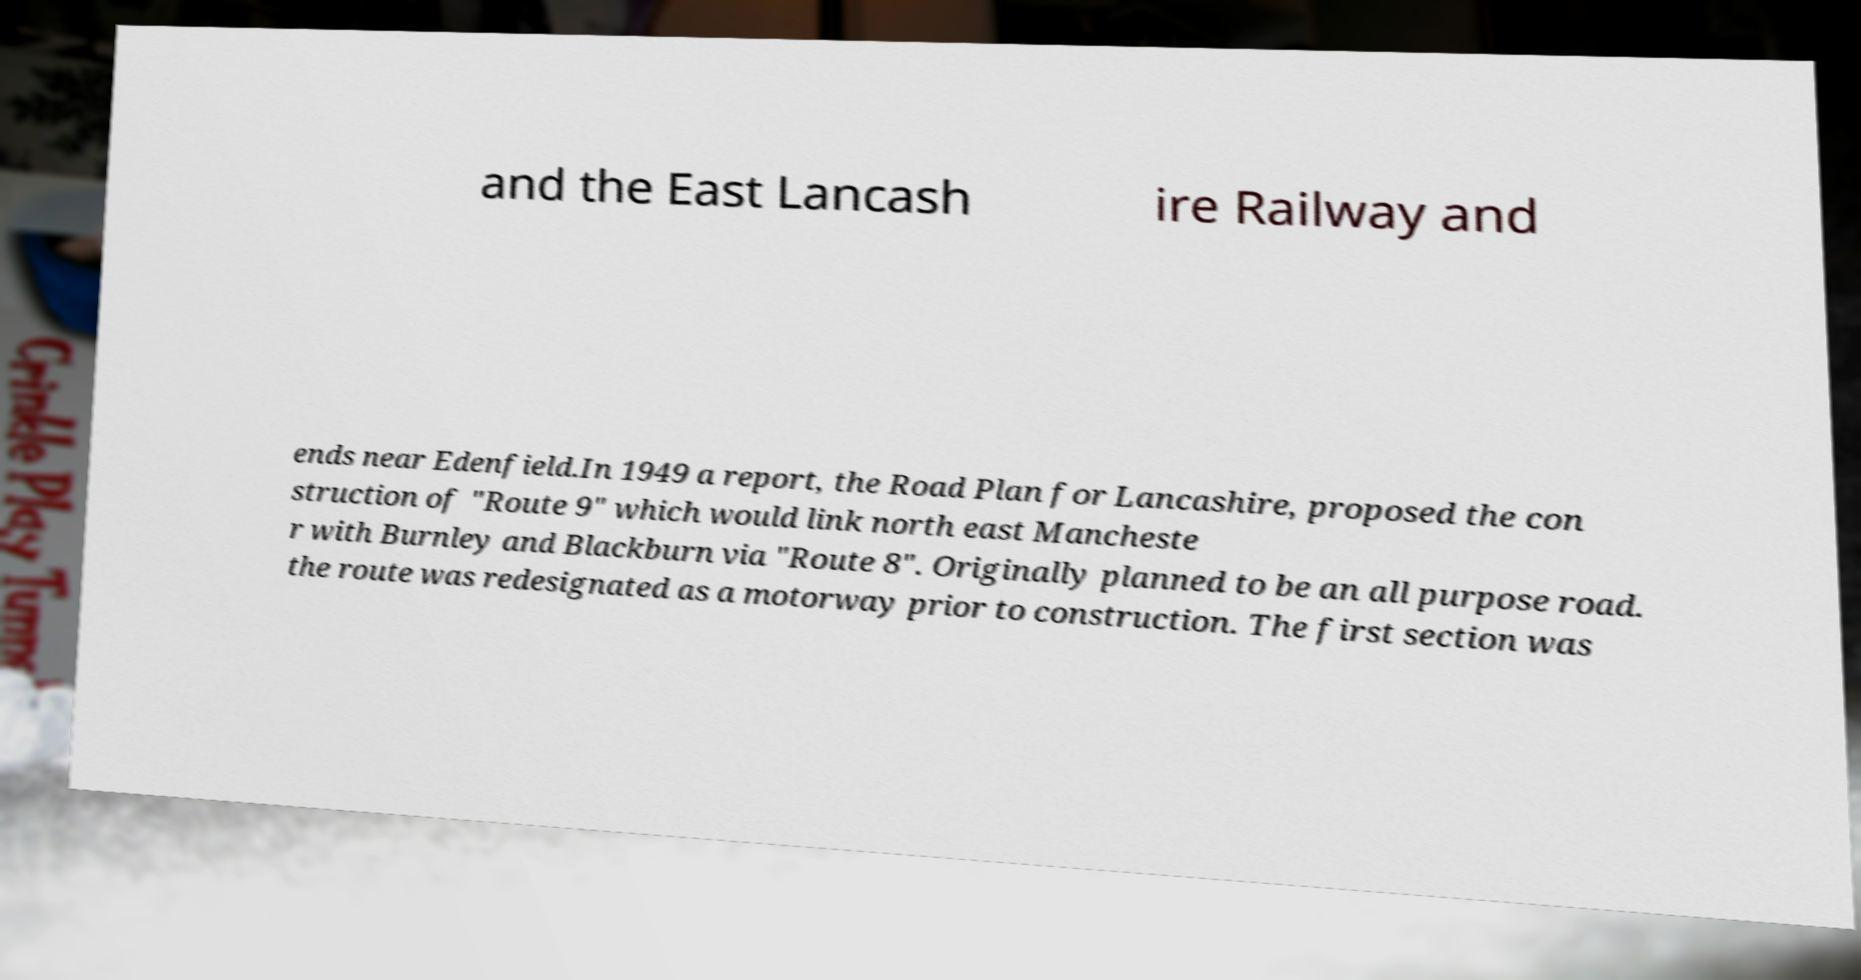I need the written content from this picture converted into text. Can you do that? and the East Lancash ire Railway and ends near Edenfield.In 1949 a report, the Road Plan for Lancashire, proposed the con struction of "Route 9" which would link north east Mancheste r with Burnley and Blackburn via "Route 8". Originally planned to be an all purpose road. the route was redesignated as a motorway prior to construction. The first section was 